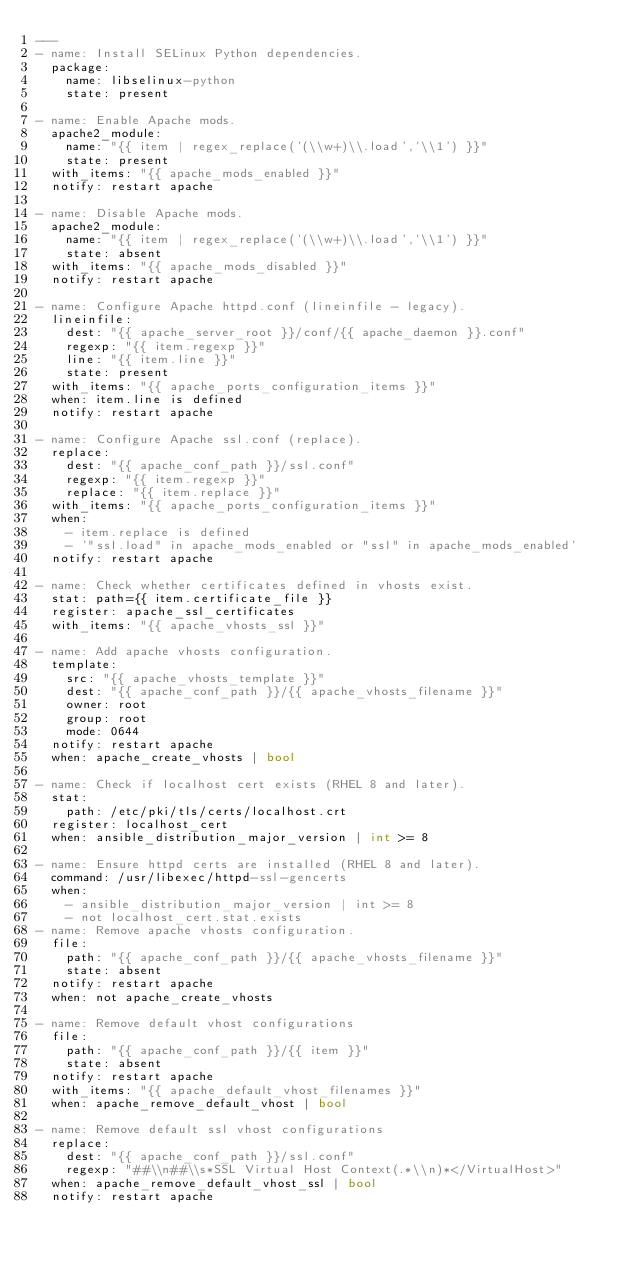Convert code to text. <code><loc_0><loc_0><loc_500><loc_500><_YAML_>---
- name: Install SELinux Python dependencies.
  package:
    name: libselinux-python
    state: present

- name: Enable Apache mods.
  apache2_module:
    name: "{{ item | regex_replace('(\\w+)\\.load','\\1') }}"
    state: present
  with_items: "{{ apache_mods_enabled }}"
  notify: restart apache

- name: Disable Apache mods.
  apache2_module:
    name: "{{ item | regex_replace('(\\w+)\\.load','\\1') }}"
    state: absent
  with_items: "{{ apache_mods_disabled }}"
  notify: restart apache

- name: Configure Apache httpd.conf (lineinfile - legacy).
  lineinfile:
    dest: "{{ apache_server_root }}/conf/{{ apache_daemon }}.conf"
    regexp: "{{ item.regexp }}"
    line: "{{ item.line }}"
    state: present
  with_items: "{{ apache_ports_configuration_items }}"
  when: item.line is defined
  notify: restart apache

- name: Configure Apache ssl.conf (replace).
  replace:
    dest: "{{ apache_conf_path }}/ssl.conf"
    regexp: "{{ item.regexp }}"
    replace: "{{ item.replace }}"
  with_items: "{{ apache_ports_configuration_items }}"
  when:
    - item.replace is defined
    - '"ssl.load" in apache_mods_enabled or "ssl" in apache_mods_enabled'
  notify: restart apache

- name: Check whether certificates defined in vhosts exist.
  stat: path={{ item.certificate_file }}
  register: apache_ssl_certificates
  with_items: "{{ apache_vhosts_ssl }}"

- name: Add apache vhosts configuration.
  template:
    src: "{{ apache_vhosts_template }}"
    dest: "{{ apache_conf_path }}/{{ apache_vhosts_filename }}"
    owner: root
    group: root
    mode: 0644
  notify: restart apache
  when: apache_create_vhosts | bool

- name: Check if localhost cert exists (RHEL 8 and later).
  stat:
    path: /etc/pki/tls/certs/localhost.crt
  register: localhost_cert
  when: ansible_distribution_major_version | int >= 8

- name: Ensure httpd certs are installed (RHEL 8 and later).
  command: /usr/libexec/httpd-ssl-gencerts
  when:
    - ansible_distribution_major_version | int >= 8
    - not localhost_cert.stat.exists
- name: Remove apache vhosts configuration.
  file:
    path: "{{ apache_conf_path }}/{{ apache_vhosts_filename }}"
    state: absent
  notify: restart apache
  when: not apache_create_vhosts

- name: Remove default vhost configurations
  file:
    path: "{{ apache_conf_path }}/{{ item }}"
    state: absent
  notify: restart apache
  with_items: "{{ apache_default_vhost_filenames }}"
  when: apache_remove_default_vhost | bool

- name: Remove default ssl vhost configurations
  replace:
    dest: "{{ apache_conf_path }}/ssl.conf"
    regexp: "##\\n##\\s*SSL Virtual Host Context(.*\\n)*</VirtualHost>"
  when: apache_remove_default_vhost_ssl | bool
  notify: restart apache
</code> 